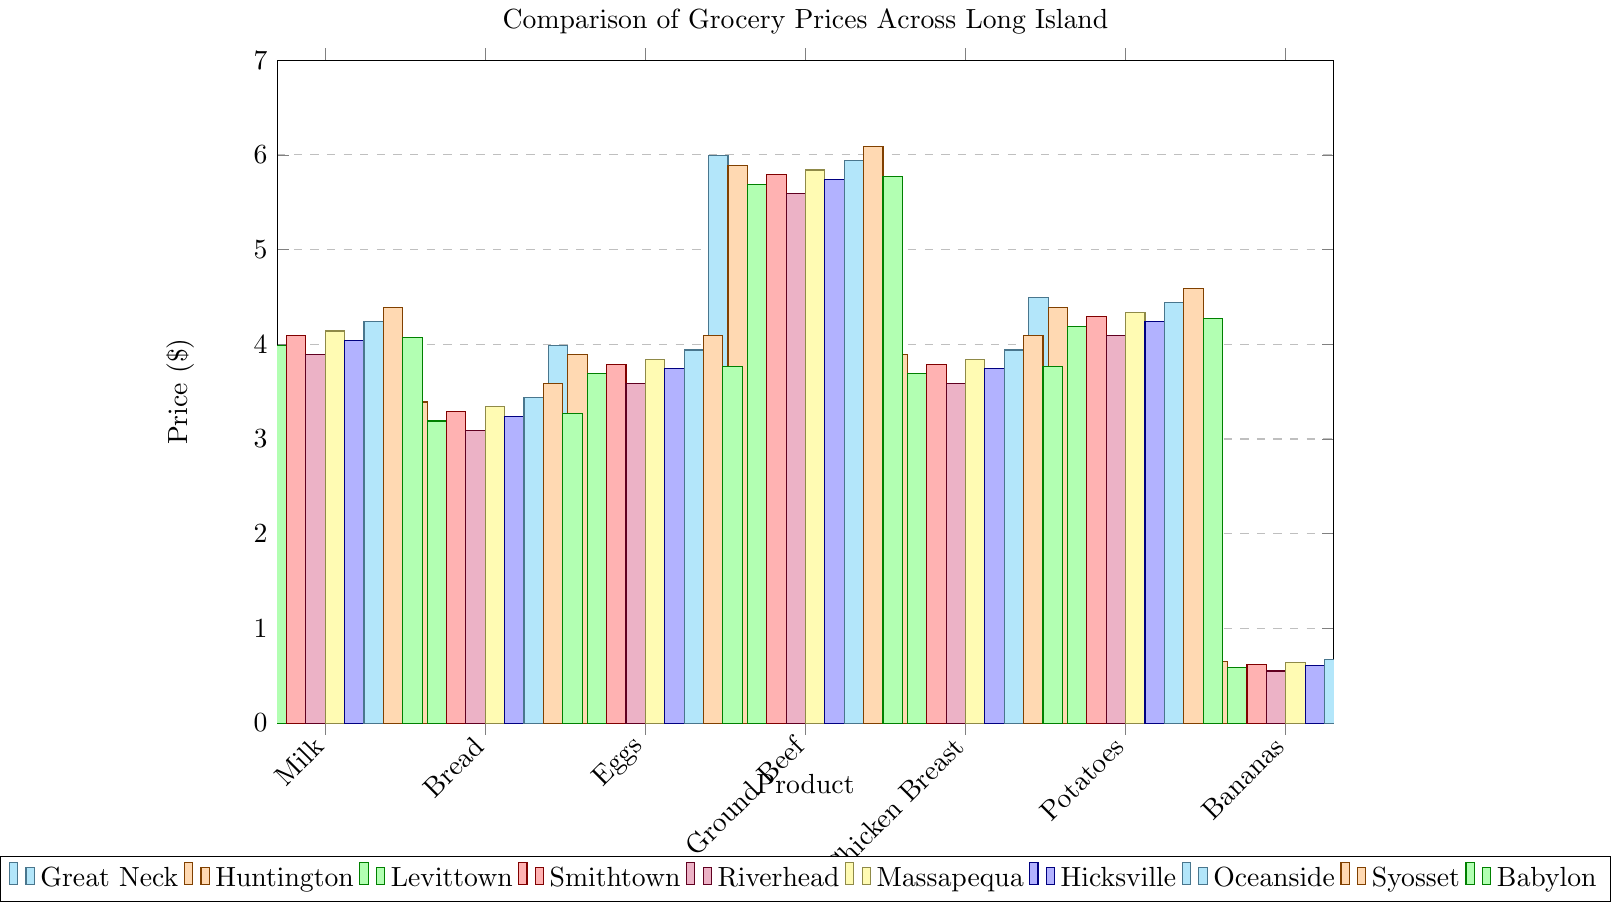Which neighborhood has the lowest price for a gallon of milk? Look at the bar heights for milk and compare them across neighborhoods. Riverhead has the lowest bar.
Answer: Riverhead Which product has the highest price in Syosset? Compare the heights of all bars representing Syosset (colored bar in all categories). Ground Beef has the highest bar.
Answer: Ground Beef How much more expensive is chicken breast in Syosset compared to Levittown? Find the heights of the bars for chicken breast in both Syosset and Levittown. Subtract the value of Levittown from Syosset (4.09 - 3.69).
Answer: $0.40 Which neighborhood provides the cheapest bananas? Look at the bar heights for bananas across all neighborhoods. Riverhead has the lowest bar.
Answer: Riverhead What's the average price of bread across all neighborhoods? Add up the prices of bread for all neighborhoods and divide by the number of neighborhoods ( (3.49+3.39+3.19+3.29+3.09+3.34+3.24+3.44+3.59+3.27) ÷ 10 ).
Answer: $3.33 Is Ground Beef in Great Neck more expensive than in Huntington? If yes, by how much? Find the bar representing Ground Beef for both Great Neck and Huntington. Calculate the difference (5.99 - 5.89).
Answer: Yes, by $0.10 Which neighborhood has the highest total price for the seven items combined? Sum the prices of all seven items for each neighborhood separately and compare the totals across neighborhoods. Syosset has the highest total.
Answer: Syosset What is the price difference between the most expensive and least expensive dozen eggs across neighborhoods? Find the maximum and minimum bar heights for eggs and calculate the difference (4.09 - 3.59).
Answer: $0.50 Are potatoes more expensive in Babylon or Massapequa? Compare the bar heights for potatoes in Babylon and Massapequa. Massapequa’s bar is higher.
Answer: Massapequa 